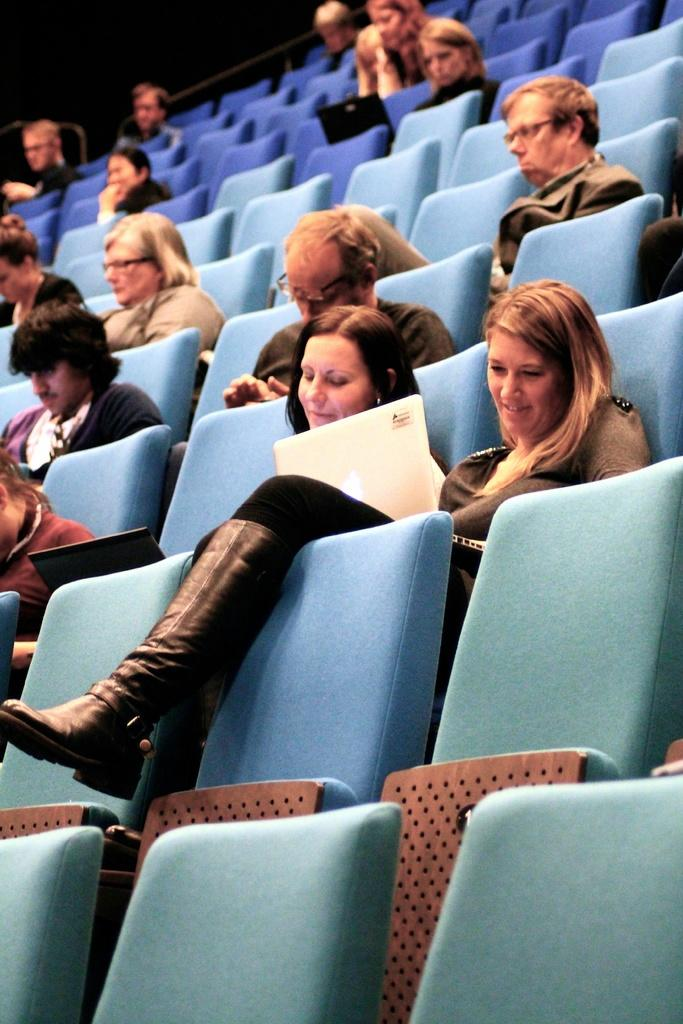What are the people in the image doing? The people in the image are sitting on chairs. What electronic devices can be seen in the image? There are laptops visible in the image. Can you describe any accessories that some people in the image are wearing? Some people in the image are wearing glasses (specs). What type of chain can be seen connecting the laptops in the image? There is no chain connecting the laptops in the image; they are not physically connected. 